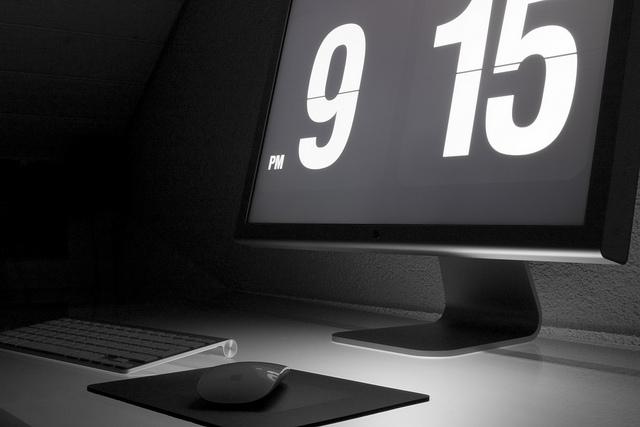Is the monitor on a stand?
Answer briefly. Yes. What time does the monitor say?
Be succinct. 9:15. Is it day or night?
Quick response, please. Night. 